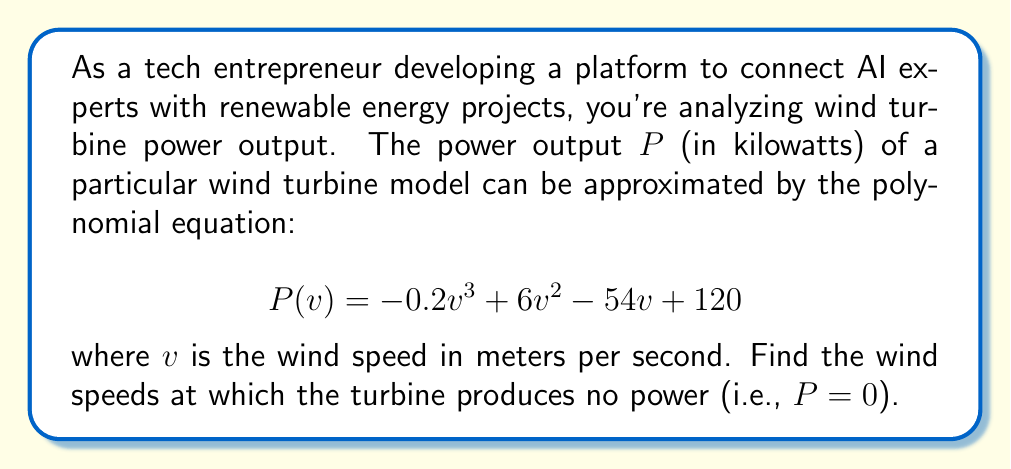Solve this math problem. To find the wind speeds at which the turbine produces no power, we need to find the roots of the polynomial equation $P(v) = 0$. Let's solve this step-by-step:

1) Set the equation equal to zero:
   $$-0.2v^3 + 6v^2 - 54v + 120 = 0$$

2) Multiply all terms by -5 to eliminate fractions:
   $$v^3 - 30v^2 + 270v - 600 = 0$$

3) This is a cubic equation. One way to solve it is to guess one root and then use polynomial long division to reduce it to a quadratic equation. By inspection or trial and error, we can see that $v = 10$ is a root.

4) Divide the polynomial by $(v - 10)$:
   $$(v^3 - 30v^2 + 270v - 600) \div (v - 10) = v^2 - 20v + 60$$

5) So our equation becomes:
   $$(v - 10)(v^2 - 20v + 60) = 0$$

6) We can solve $v^2 - 20v + 60 = 0$ using the quadratic formula:
   $$v = \frac{-b \pm \sqrt{b^2 - 4ac}}{2a}$$
   where $a = 1$, $b = -20$, and $c = 60$

7) Plugging in these values:
   $$v = \frac{20 \pm \sqrt{400 - 240}}{2} = \frac{20 \pm \sqrt{160}}{2} = \frac{20 \pm 4\sqrt{10}}{2}$$

8) Simplifying:
   $$v = 10 \pm 2\sqrt{10}$$

Therefore, the three roots are:
- $v_1 = 10$
- $v_2 = 10 + 2\sqrt{10} \approx 16.3$
- $v_3 = 10 - 2\sqrt{10} \approx 3.7$
Answer: The wind turbine produces no power at wind speeds of approximately 3.7 m/s, 10 m/s, and 16.3 m/s. 